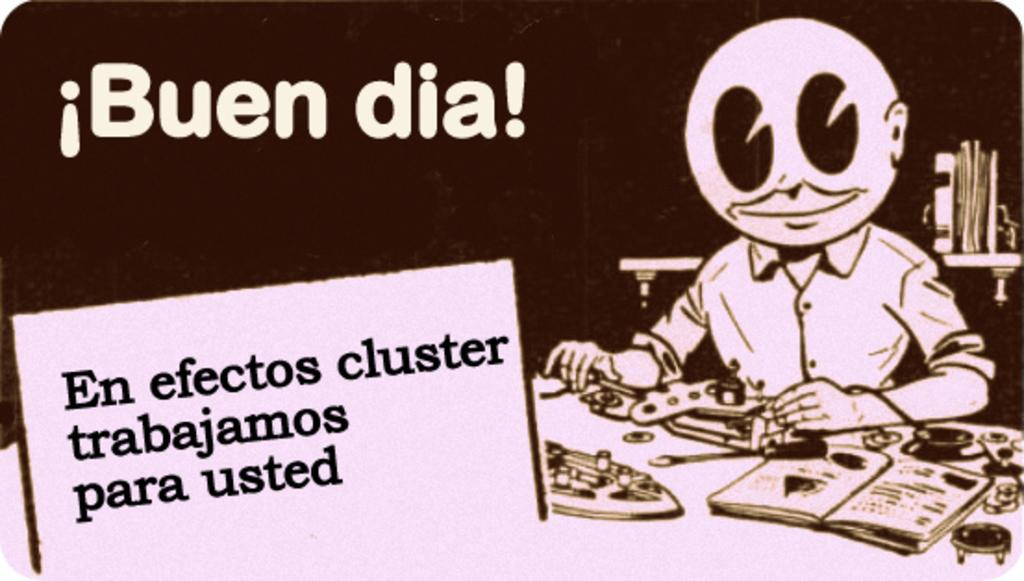What is featured in the picture? There is a poster in the picture. What can be found on the poster? The poster contains text and a picture on the side. What type of fruit is being held by the friend in the picture? There is no fruit or friend present in the picture; it only features a poster with text and a picture on the side. 